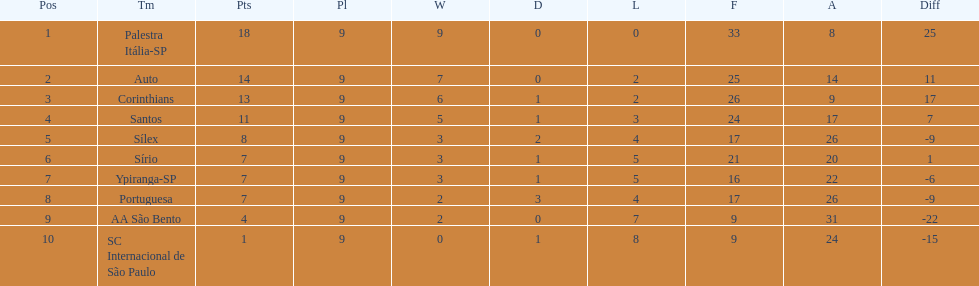In 1926 brazilian football,aside from the first place team, what other teams had winning records? Auto, Corinthians, Santos. Parse the full table. {'header': ['Pos', 'Tm', 'Pts', 'Pl', 'W', 'D', 'L', 'F', 'A', 'Diff'], 'rows': [['1', 'Palestra Itália-SP', '18', '9', '9', '0', '0', '33', '8', '25'], ['2', 'Auto', '14', '9', '7', '0', '2', '25', '14', '11'], ['3', 'Corinthians', '13', '9', '6', '1', '2', '26', '9', '17'], ['4', 'Santos', '11', '9', '5', '1', '3', '24', '17', '7'], ['5', 'Sílex', '8', '9', '3', '2', '4', '17', '26', '-9'], ['6', 'Sírio', '7', '9', '3', '1', '5', '21', '20', '1'], ['7', 'Ypiranga-SP', '7', '9', '3', '1', '5', '16', '22', '-6'], ['8', 'Portuguesa', '7', '9', '2', '3', '4', '17', '26', '-9'], ['9', 'AA São Bento', '4', '9', '2', '0', '7', '9', '31', '-22'], ['10', 'SC Internacional de São Paulo', '1', '9', '0', '1', '8', '9', '24', '-15']]} 